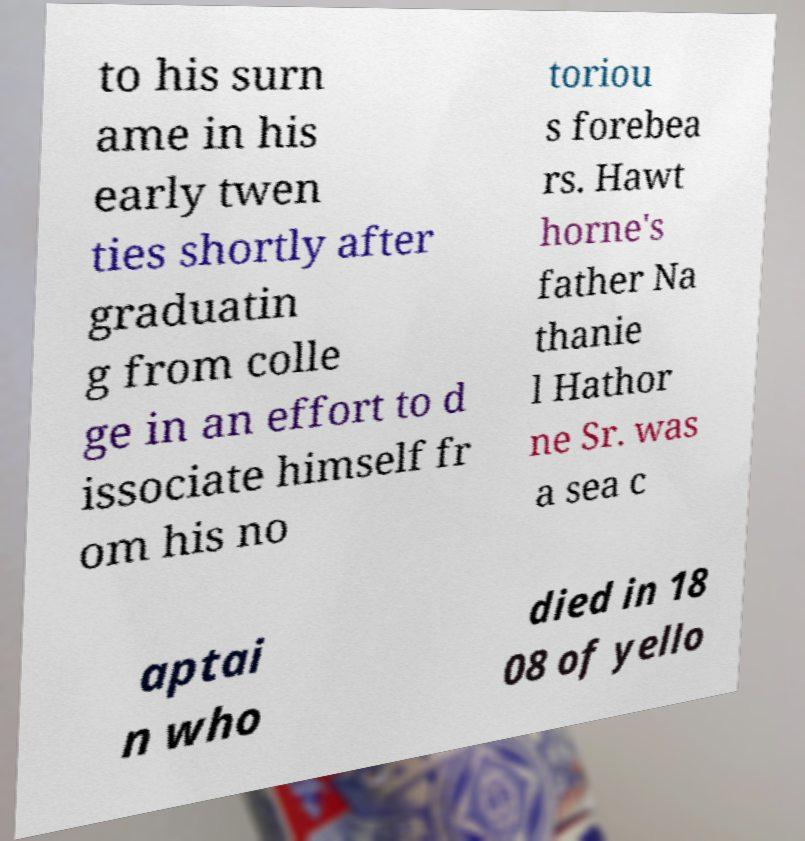For documentation purposes, I need the text within this image transcribed. Could you provide that? to his surn ame in his early twen ties shortly after graduatin g from colle ge in an effort to d issociate himself fr om his no toriou s forebea rs. Hawt horne's father Na thanie l Hathor ne Sr. was a sea c aptai n who died in 18 08 of yello 